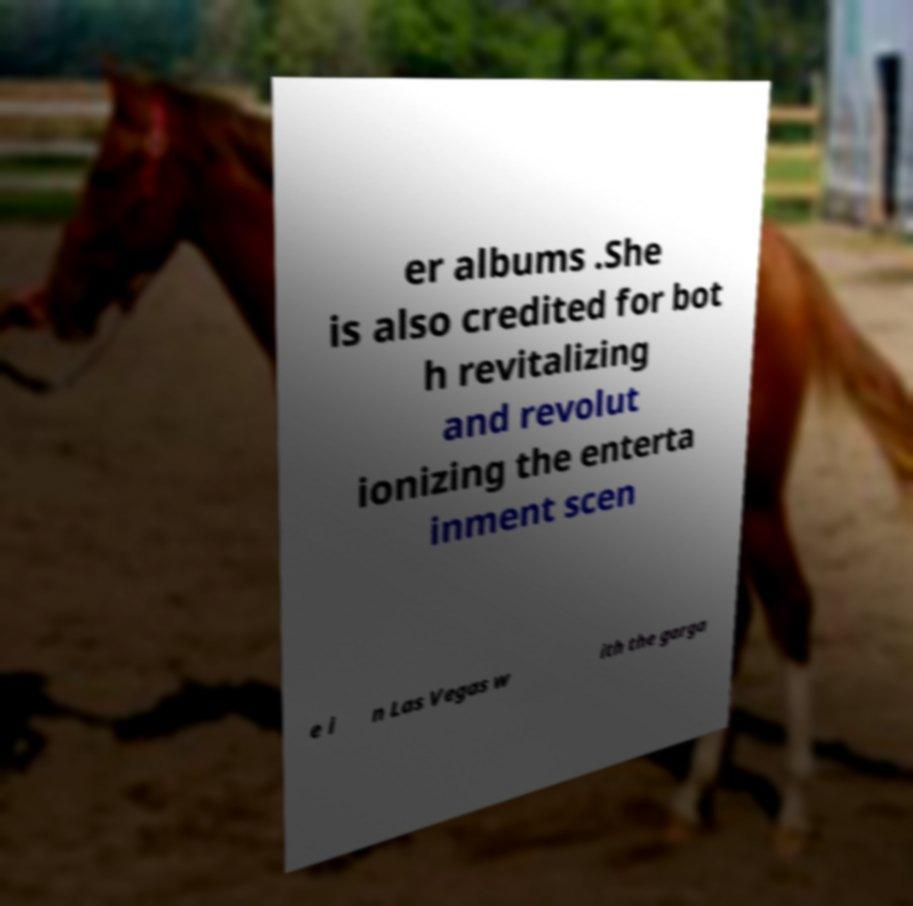Can you read and provide the text displayed in the image?This photo seems to have some interesting text. Can you extract and type it out for me? er albums .She is also credited for bot h revitalizing and revolut ionizing the enterta inment scen e i n Las Vegas w ith the garga 